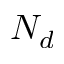Convert formula to latex. <formula><loc_0><loc_0><loc_500><loc_500>N _ { d }</formula> 